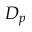<formula> <loc_0><loc_0><loc_500><loc_500>D _ { p }</formula> 